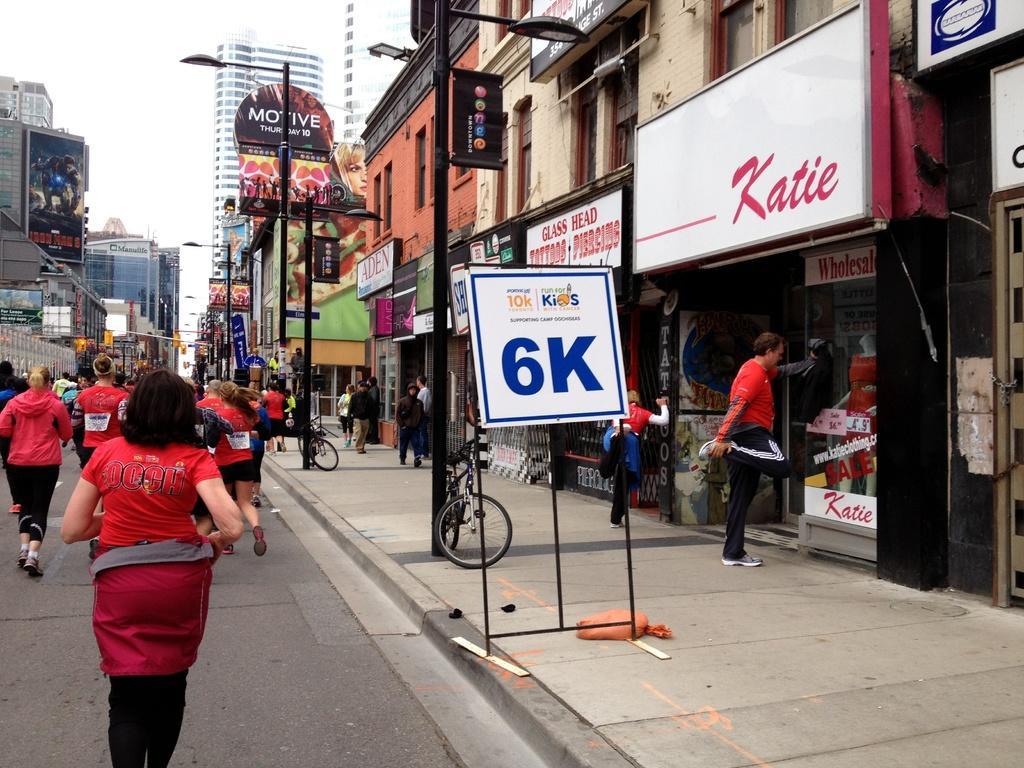Describe this image in one or two sentences. In this picture we can see so so many buildings beside the road and some are running on the road. 